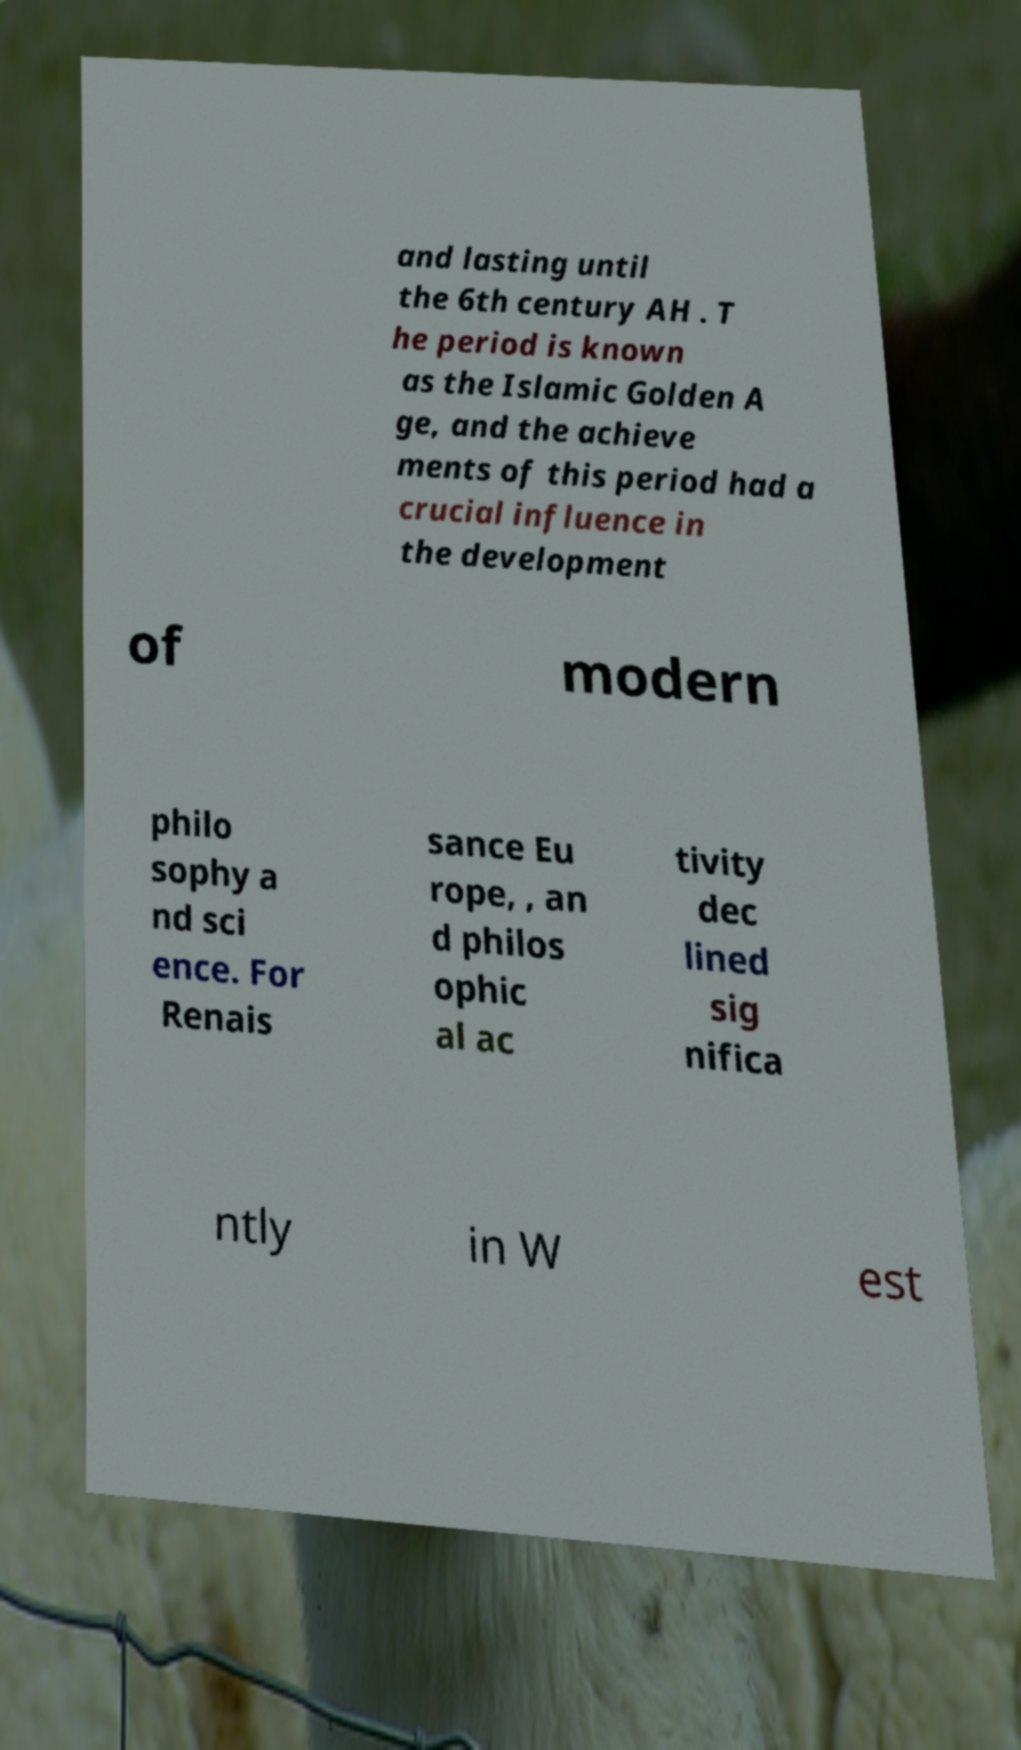Could you assist in decoding the text presented in this image and type it out clearly? and lasting until the 6th century AH . T he period is known as the Islamic Golden A ge, and the achieve ments of this period had a crucial influence in the development of modern philo sophy a nd sci ence. For Renais sance Eu rope, , an d philos ophic al ac tivity dec lined sig nifica ntly in W est 